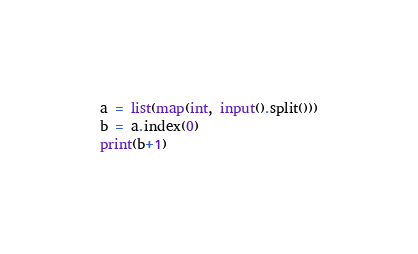Convert code to text. <code><loc_0><loc_0><loc_500><loc_500><_Python_>a = list(map(int, input().split()))
b = a.index(0)
print(b+1)
</code> 